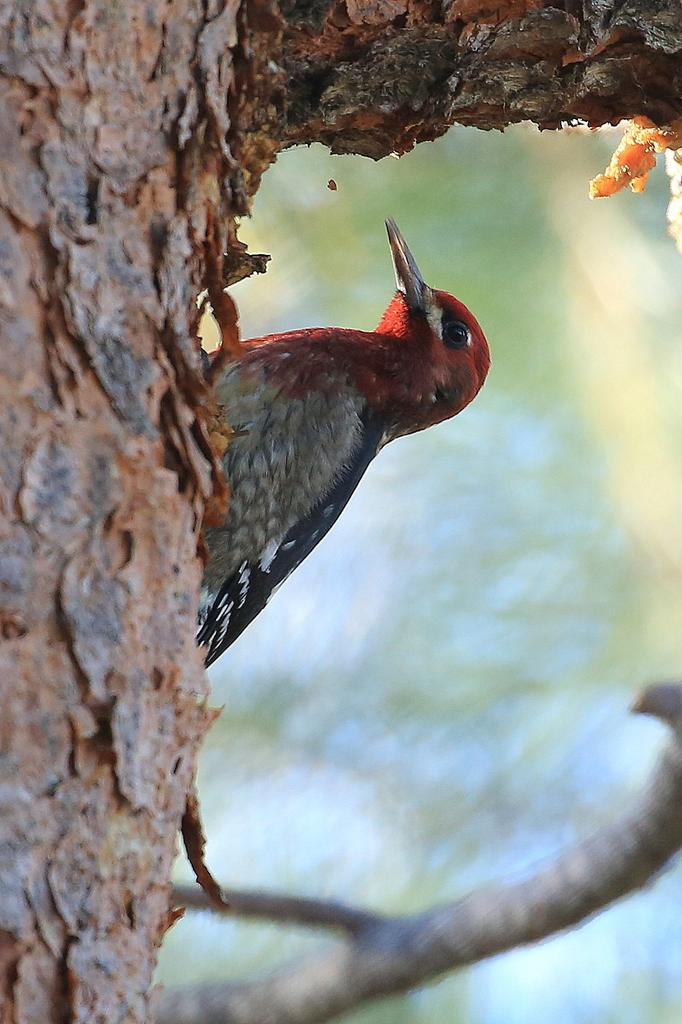What type of animal can be seen in the image? There is a bird in the image. Where is the bird located? The bird is on a tree trunk. Can you describe the background of the image? The background of the image is blurred. What type of lace is the bird using to fly in the image? There is no lace present in the image, and birds do not use lace to fly. 